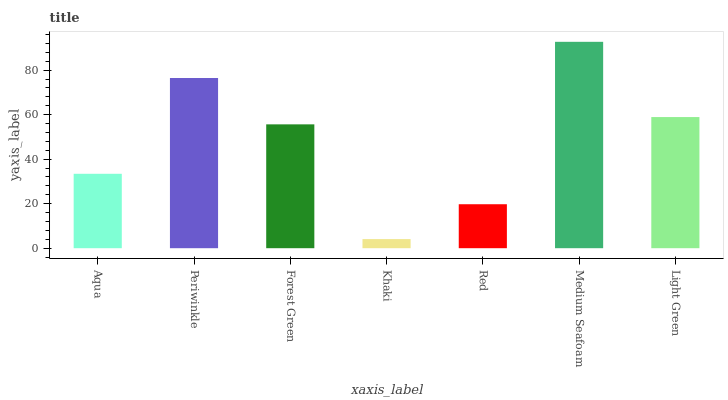Is Khaki the minimum?
Answer yes or no. Yes. Is Medium Seafoam the maximum?
Answer yes or no. Yes. Is Periwinkle the minimum?
Answer yes or no. No. Is Periwinkle the maximum?
Answer yes or no. No. Is Periwinkle greater than Aqua?
Answer yes or no. Yes. Is Aqua less than Periwinkle?
Answer yes or no. Yes. Is Aqua greater than Periwinkle?
Answer yes or no. No. Is Periwinkle less than Aqua?
Answer yes or no. No. Is Forest Green the high median?
Answer yes or no. Yes. Is Forest Green the low median?
Answer yes or no. Yes. Is Medium Seafoam the high median?
Answer yes or no. No. Is Khaki the low median?
Answer yes or no. No. 